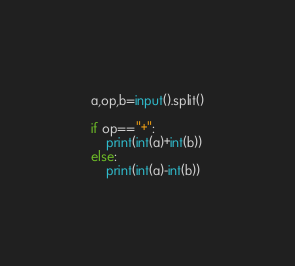<code> <loc_0><loc_0><loc_500><loc_500><_Python_>a,op,b=input().split()

if op=="+":
    print(int(a)+int(b))
else:
    print(int(a)-int(b))</code> 